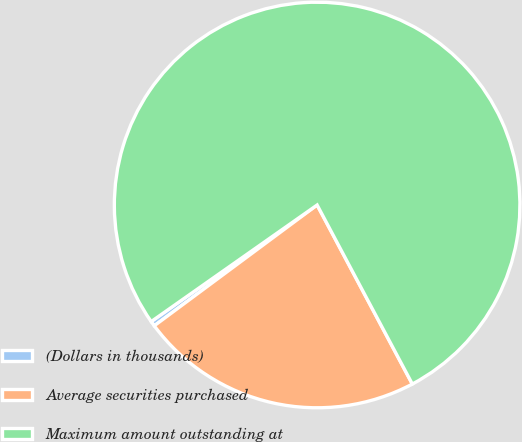<chart> <loc_0><loc_0><loc_500><loc_500><pie_chart><fcel>(Dollars in thousands)<fcel>Average securities purchased<fcel>Maximum amount outstanding at<nl><fcel>0.41%<fcel>22.62%<fcel>76.97%<nl></chart> 